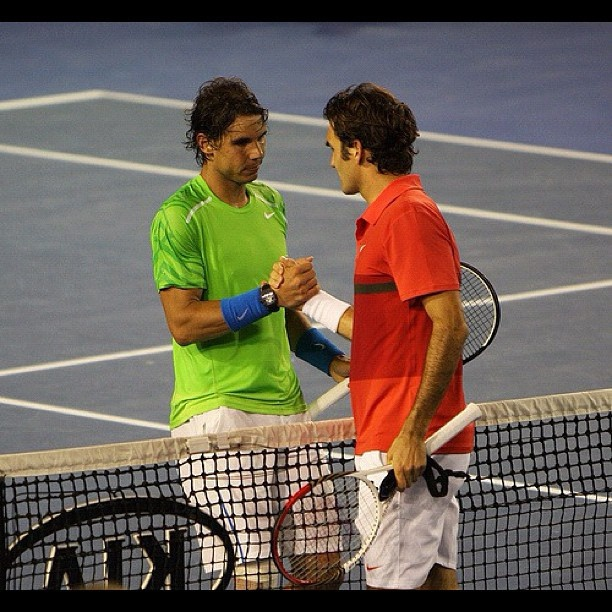Describe the objects in this image and their specific colors. I can see people in black, olive, brown, and maroon tones, people in black, brown, red, and maroon tones, tennis racket in black, gray, maroon, and darkgray tones, and tennis racket in black and gray tones in this image. 